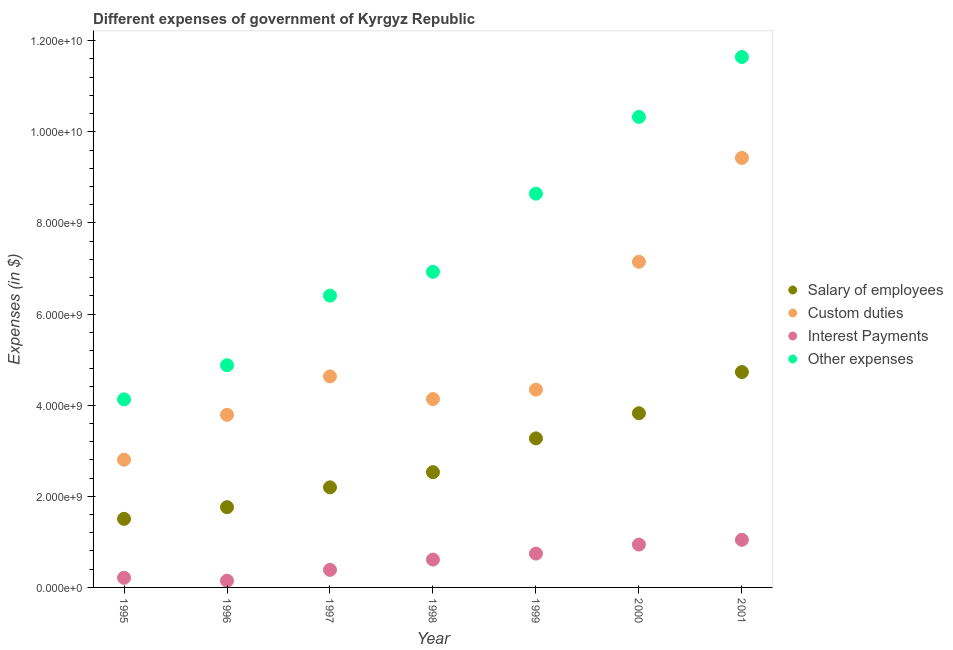Is the number of dotlines equal to the number of legend labels?
Your response must be concise. Yes. What is the amount spent on custom duties in 1999?
Give a very brief answer. 4.34e+09. Across all years, what is the maximum amount spent on salary of employees?
Your answer should be very brief. 4.73e+09. Across all years, what is the minimum amount spent on salary of employees?
Ensure brevity in your answer.  1.51e+09. In which year was the amount spent on custom duties maximum?
Keep it short and to the point. 2001. In which year was the amount spent on custom duties minimum?
Make the answer very short. 1995. What is the total amount spent on salary of employees in the graph?
Offer a very short reply. 1.98e+1. What is the difference between the amount spent on interest payments in 1995 and that in 1997?
Offer a very short reply. -1.74e+08. What is the difference between the amount spent on salary of employees in 1998 and the amount spent on other expenses in 1996?
Ensure brevity in your answer.  -2.35e+09. What is the average amount spent on salary of employees per year?
Ensure brevity in your answer.  2.83e+09. In the year 1995, what is the difference between the amount spent on custom duties and amount spent on other expenses?
Make the answer very short. -1.32e+09. In how many years, is the amount spent on salary of employees greater than 4800000000 $?
Provide a short and direct response. 0. What is the ratio of the amount spent on custom duties in 1996 to that in 1997?
Offer a very short reply. 0.82. Is the amount spent on salary of employees in 2000 less than that in 2001?
Your answer should be compact. Yes. Is the difference between the amount spent on custom duties in 1995 and 1997 greater than the difference between the amount spent on interest payments in 1995 and 1997?
Make the answer very short. No. What is the difference between the highest and the second highest amount spent on other expenses?
Your answer should be very brief. 1.32e+09. What is the difference between the highest and the lowest amount spent on other expenses?
Ensure brevity in your answer.  7.52e+09. In how many years, is the amount spent on other expenses greater than the average amount spent on other expenses taken over all years?
Keep it short and to the point. 3. Is it the case that in every year, the sum of the amount spent on other expenses and amount spent on custom duties is greater than the sum of amount spent on salary of employees and amount spent on interest payments?
Make the answer very short. Yes. Is it the case that in every year, the sum of the amount spent on salary of employees and amount spent on custom duties is greater than the amount spent on interest payments?
Provide a succinct answer. Yes. Does the amount spent on other expenses monotonically increase over the years?
Provide a succinct answer. Yes. Is the amount spent on other expenses strictly greater than the amount spent on salary of employees over the years?
Give a very brief answer. Yes. How many dotlines are there?
Provide a short and direct response. 4. What is the difference between two consecutive major ticks on the Y-axis?
Make the answer very short. 2.00e+09. Are the values on the major ticks of Y-axis written in scientific E-notation?
Your answer should be very brief. Yes. Does the graph contain any zero values?
Make the answer very short. No. Does the graph contain grids?
Keep it short and to the point. No. How many legend labels are there?
Your answer should be very brief. 4. What is the title of the graph?
Your answer should be compact. Different expenses of government of Kyrgyz Republic. Does "Revenue mobilization" appear as one of the legend labels in the graph?
Ensure brevity in your answer.  No. What is the label or title of the X-axis?
Make the answer very short. Year. What is the label or title of the Y-axis?
Ensure brevity in your answer.  Expenses (in $). What is the Expenses (in $) in Salary of employees in 1995?
Your response must be concise. 1.51e+09. What is the Expenses (in $) of Custom duties in 1995?
Make the answer very short. 2.80e+09. What is the Expenses (in $) of Interest Payments in 1995?
Give a very brief answer. 2.12e+08. What is the Expenses (in $) in Other expenses in 1995?
Give a very brief answer. 4.13e+09. What is the Expenses (in $) of Salary of employees in 1996?
Keep it short and to the point. 1.76e+09. What is the Expenses (in $) in Custom duties in 1996?
Your answer should be compact. 3.79e+09. What is the Expenses (in $) in Interest Payments in 1996?
Your answer should be very brief. 1.48e+08. What is the Expenses (in $) in Other expenses in 1996?
Give a very brief answer. 4.88e+09. What is the Expenses (in $) of Salary of employees in 1997?
Your answer should be compact. 2.20e+09. What is the Expenses (in $) in Custom duties in 1997?
Keep it short and to the point. 4.63e+09. What is the Expenses (in $) of Interest Payments in 1997?
Offer a terse response. 3.85e+08. What is the Expenses (in $) in Other expenses in 1997?
Offer a very short reply. 6.41e+09. What is the Expenses (in $) in Salary of employees in 1998?
Your answer should be compact. 2.53e+09. What is the Expenses (in $) of Custom duties in 1998?
Make the answer very short. 4.14e+09. What is the Expenses (in $) in Interest Payments in 1998?
Your response must be concise. 6.11e+08. What is the Expenses (in $) of Other expenses in 1998?
Give a very brief answer. 6.93e+09. What is the Expenses (in $) of Salary of employees in 1999?
Your answer should be compact. 3.27e+09. What is the Expenses (in $) in Custom duties in 1999?
Give a very brief answer. 4.34e+09. What is the Expenses (in $) of Interest Payments in 1999?
Offer a very short reply. 7.43e+08. What is the Expenses (in $) of Other expenses in 1999?
Your answer should be compact. 8.64e+09. What is the Expenses (in $) of Salary of employees in 2000?
Give a very brief answer. 3.82e+09. What is the Expenses (in $) of Custom duties in 2000?
Provide a short and direct response. 7.15e+09. What is the Expenses (in $) of Interest Payments in 2000?
Make the answer very short. 9.41e+08. What is the Expenses (in $) of Other expenses in 2000?
Your answer should be compact. 1.03e+1. What is the Expenses (in $) in Salary of employees in 2001?
Provide a short and direct response. 4.73e+09. What is the Expenses (in $) of Custom duties in 2001?
Make the answer very short. 9.43e+09. What is the Expenses (in $) of Interest Payments in 2001?
Ensure brevity in your answer.  1.05e+09. What is the Expenses (in $) in Other expenses in 2001?
Offer a terse response. 1.16e+1. Across all years, what is the maximum Expenses (in $) of Salary of employees?
Your answer should be compact. 4.73e+09. Across all years, what is the maximum Expenses (in $) in Custom duties?
Make the answer very short. 9.43e+09. Across all years, what is the maximum Expenses (in $) of Interest Payments?
Provide a succinct answer. 1.05e+09. Across all years, what is the maximum Expenses (in $) of Other expenses?
Provide a succinct answer. 1.16e+1. Across all years, what is the minimum Expenses (in $) of Salary of employees?
Provide a succinct answer. 1.51e+09. Across all years, what is the minimum Expenses (in $) in Custom duties?
Offer a terse response. 2.80e+09. Across all years, what is the minimum Expenses (in $) of Interest Payments?
Provide a short and direct response. 1.48e+08. Across all years, what is the minimum Expenses (in $) of Other expenses?
Keep it short and to the point. 4.13e+09. What is the total Expenses (in $) in Salary of employees in the graph?
Provide a short and direct response. 1.98e+1. What is the total Expenses (in $) in Custom duties in the graph?
Ensure brevity in your answer.  3.63e+1. What is the total Expenses (in $) of Interest Payments in the graph?
Ensure brevity in your answer.  4.09e+09. What is the total Expenses (in $) in Other expenses in the graph?
Keep it short and to the point. 5.30e+1. What is the difference between the Expenses (in $) of Salary of employees in 1995 and that in 1996?
Your answer should be compact. -2.56e+08. What is the difference between the Expenses (in $) of Custom duties in 1995 and that in 1996?
Make the answer very short. -9.86e+08. What is the difference between the Expenses (in $) of Interest Payments in 1995 and that in 1996?
Your answer should be compact. 6.33e+07. What is the difference between the Expenses (in $) in Other expenses in 1995 and that in 1996?
Your answer should be very brief. -7.50e+08. What is the difference between the Expenses (in $) of Salary of employees in 1995 and that in 1997?
Offer a very short reply. -6.91e+08. What is the difference between the Expenses (in $) of Custom duties in 1995 and that in 1997?
Ensure brevity in your answer.  -1.83e+09. What is the difference between the Expenses (in $) in Interest Payments in 1995 and that in 1997?
Your answer should be very brief. -1.74e+08. What is the difference between the Expenses (in $) of Other expenses in 1995 and that in 1997?
Your response must be concise. -2.28e+09. What is the difference between the Expenses (in $) of Salary of employees in 1995 and that in 1998?
Offer a terse response. -1.02e+09. What is the difference between the Expenses (in $) of Custom duties in 1995 and that in 1998?
Make the answer very short. -1.33e+09. What is the difference between the Expenses (in $) of Interest Payments in 1995 and that in 1998?
Your response must be concise. -4.00e+08. What is the difference between the Expenses (in $) in Other expenses in 1995 and that in 1998?
Your answer should be compact. -2.80e+09. What is the difference between the Expenses (in $) of Salary of employees in 1995 and that in 1999?
Make the answer very short. -1.77e+09. What is the difference between the Expenses (in $) of Custom duties in 1995 and that in 1999?
Your answer should be very brief. -1.54e+09. What is the difference between the Expenses (in $) in Interest Payments in 1995 and that in 1999?
Give a very brief answer. -5.31e+08. What is the difference between the Expenses (in $) of Other expenses in 1995 and that in 1999?
Offer a terse response. -4.52e+09. What is the difference between the Expenses (in $) of Salary of employees in 1995 and that in 2000?
Provide a short and direct response. -2.32e+09. What is the difference between the Expenses (in $) in Custom duties in 1995 and that in 2000?
Give a very brief answer. -4.35e+09. What is the difference between the Expenses (in $) in Interest Payments in 1995 and that in 2000?
Offer a terse response. -7.29e+08. What is the difference between the Expenses (in $) of Other expenses in 1995 and that in 2000?
Your answer should be compact. -6.20e+09. What is the difference between the Expenses (in $) in Salary of employees in 1995 and that in 2001?
Your answer should be compact. -3.22e+09. What is the difference between the Expenses (in $) in Custom duties in 1995 and that in 2001?
Your response must be concise. -6.63e+09. What is the difference between the Expenses (in $) of Interest Payments in 1995 and that in 2001?
Your answer should be compact. -8.34e+08. What is the difference between the Expenses (in $) of Other expenses in 1995 and that in 2001?
Provide a succinct answer. -7.52e+09. What is the difference between the Expenses (in $) in Salary of employees in 1996 and that in 1997?
Provide a succinct answer. -4.35e+08. What is the difference between the Expenses (in $) of Custom duties in 1996 and that in 1997?
Your response must be concise. -8.42e+08. What is the difference between the Expenses (in $) in Interest Payments in 1996 and that in 1997?
Offer a terse response. -2.37e+08. What is the difference between the Expenses (in $) in Other expenses in 1996 and that in 1997?
Make the answer very short. -1.53e+09. What is the difference between the Expenses (in $) in Salary of employees in 1996 and that in 1998?
Make the answer very short. -7.68e+08. What is the difference between the Expenses (in $) of Custom duties in 1996 and that in 1998?
Make the answer very short. -3.46e+08. What is the difference between the Expenses (in $) in Interest Payments in 1996 and that in 1998?
Your answer should be compact. -4.63e+08. What is the difference between the Expenses (in $) of Other expenses in 1996 and that in 1998?
Keep it short and to the point. -2.05e+09. What is the difference between the Expenses (in $) in Salary of employees in 1996 and that in 1999?
Offer a terse response. -1.51e+09. What is the difference between the Expenses (in $) in Custom duties in 1996 and that in 1999?
Offer a very short reply. -5.52e+08. What is the difference between the Expenses (in $) of Interest Payments in 1996 and that in 1999?
Provide a short and direct response. -5.95e+08. What is the difference between the Expenses (in $) of Other expenses in 1996 and that in 1999?
Offer a very short reply. -3.77e+09. What is the difference between the Expenses (in $) in Salary of employees in 1996 and that in 2000?
Your answer should be very brief. -2.06e+09. What is the difference between the Expenses (in $) in Custom duties in 1996 and that in 2000?
Provide a succinct answer. -3.36e+09. What is the difference between the Expenses (in $) in Interest Payments in 1996 and that in 2000?
Your answer should be very brief. -7.92e+08. What is the difference between the Expenses (in $) of Other expenses in 1996 and that in 2000?
Provide a succinct answer. -5.45e+09. What is the difference between the Expenses (in $) in Salary of employees in 1996 and that in 2001?
Offer a very short reply. -2.97e+09. What is the difference between the Expenses (in $) of Custom duties in 1996 and that in 2001?
Make the answer very short. -5.64e+09. What is the difference between the Expenses (in $) of Interest Payments in 1996 and that in 2001?
Ensure brevity in your answer.  -8.97e+08. What is the difference between the Expenses (in $) of Other expenses in 1996 and that in 2001?
Ensure brevity in your answer.  -6.77e+09. What is the difference between the Expenses (in $) of Salary of employees in 1997 and that in 1998?
Offer a very short reply. -3.33e+08. What is the difference between the Expenses (in $) of Custom duties in 1997 and that in 1998?
Make the answer very short. 4.96e+08. What is the difference between the Expenses (in $) in Interest Payments in 1997 and that in 1998?
Ensure brevity in your answer.  -2.26e+08. What is the difference between the Expenses (in $) of Other expenses in 1997 and that in 1998?
Ensure brevity in your answer.  -5.22e+08. What is the difference between the Expenses (in $) of Salary of employees in 1997 and that in 1999?
Offer a very short reply. -1.08e+09. What is the difference between the Expenses (in $) in Custom duties in 1997 and that in 1999?
Your response must be concise. 2.90e+08. What is the difference between the Expenses (in $) of Interest Payments in 1997 and that in 1999?
Your answer should be very brief. -3.58e+08. What is the difference between the Expenses (in $) of Other expenses in 1997 and that in 1999?
Offer a very short reply. -2.24e+09. What is the difference between the Expenses (in $) in Salary of employees in 1997 and that in 2000?
Provide a succinct answer. -1.63e+09. What is the difference between the Expenses (in $) of Custom duties in 1997 and that in 2000?
Keep it short and to the point. -2.52e+09. What is the difference between the Expenses (in $) of Interest Payments in 1997 and that in 2000?
Your response must be concise. -5.55e+08. What is the difference between the Expenses (in $) in Other expenses in 1997 and that in 2000?
Offer a very short reply. -3.92e+09. What is the difference between the Expenses (in $) in Salary of employees in 1997 and that in 2001?
Your response must be concise. -2.53e+09. What is the difference between the Expenses (in $) of Custom duties in 1997 and that in 2001?
Ensure brevity in your answer.  -4.80e+09. What is the difference between the Expenses (in $) in Interest Payments in 1997 and that in 2001?
Provide a short and direct response. -6.60e+08. What is the difference between the Expenses (in $) of Other expenses in 1997 and that in 2001?
Your answer should be very brief. -5.24e+09. What is the difference between the Expenses (in $) in Salary of employees in 1998 and that in 1999?
Your answer should be very brief. -7.42e+08. What is the difference between the Expenses (in $) of Custom duties in 1998 and that in 1999?
Your answer should be compact. -2.06e+08. What is the difference between the Expenses (in $) of Interest Payments in 1998 and that in 1999?
Provide a short and direct response. -1.32e+08. What is the difference between the Expenses (in $) in Other expenses in 1998 and that in 1999?
Give a very brief answer. -1.72e+09. What is the difference between the Expenses (in $) in Salary of employees in 1998 and that in 2000?
Provide a succinct answer. -1.29e+09. What is the difference between the Expenses (in $) in Custom duties in 1998 and that in 2000?
Offer a terse response. -3.01e+09. What is the difference between the Expenses (in $) in Interest Payments in 1998 and that in 2000?
Your answer should be very brief. -3.29e+08. What is the difference between the Expenses (in $) in Other expenses in 1998 and that in 2000?
Keep it short and to the point. -3.40e+09. What is the difference between the Expenses (in $) in Salary of employees in 1998 and that in 2001?
Keep it short and to the point. -2.20e+09. What is the difference between the Expenses (in $) of Custom duties in 1998 and that in 2001?
Your answer should be compact. -5.29e+09. What is the difference between the Expenses (in $) of Interest Payments in 1998 and that in 2001?
Offer a very short reply. -4.34e+08. What is the difference between the Expenses (in $) of Other expenses in 1998 and that in 2001?
Your response must be concise. -4.72e+09. What is the difference between the Expenses (in $) in Salary of employees in 1999 and that in 2000?
Your response must be concise. -5.52e+08. What is the difference between the Expenses (in $) in Custom duties in 1999 and that in 2000?
Ensure brevity in your answer.  -2.81e+09. What is the difference between the Expenses (in $) in Interest Payments in 1999 and that in 2000?
Your answer should be very brief. -1.98e+08. What is the difference between the Expenses (in $) in Other expenses in 1999 and that in 2000?
Offer a terse response. -1.68e+09. What is the difference between the Expenses (in $) in Salary of employees in 1999 and that in 2001?
Keep it short and to the point. -1.46e+09. What is the difference between the Expenses (in $) of Custom duties in 1999 and that in 2001?
Offer a very short reply. -5.09e+09. What is the difference between the Expenses (in $) in Interest Payments in 1999 and that in 2001?
Your answer should be compact. -3.02e+08. What is the difference between the Expenses (in $) of Other expenses in 1999 and that in 2001?
Offer a terse response. -3.00e+09. What is the difference between the Expenses (in $) of Salary of employees in 2000 and that in 2001?
Your answer should be very brief. -9.04e+08. What is the difference between the Expenses (in $) of Custom duties in 2000 and that in 2001?
Keep it short and to the point. -2.28e+09. What is the difference between the Expenses (in $) in Interest Payments in 2000 and that in 2001?
Your response must be concise. -1.05e+08. What is the difference between the Expenses (in $) in Other expenses in 2000 and that in 2001?
Give a very brief answer. -1.32e+09. What is the difference between the Expenses (in $) of Salary of employees in 1995 and the Expenses (in $) of Custom duties in 1996?
Keep it short and to the point. -2.28e+09. What is the difference between the Expenses (in $) in Salary of employees in 1995 and the Expenses (in $) in Interest Payments in 1996?
Your answer should be compact. 1.36e+09. What is the difference between the Expenses (in $) in Salary of employees in 1995 and the Expenses (in $) in Other expenses in 1996?
Keep it short and to the point. -3.37e+09. What is the difference between the Expenses (in $) of Custom duties in 1995 and the Expenses (in $) of Interest Payments in 1996?
Your answer should be compact. 2.65e+09. What is the difference between the Expenses (in $) of Custom duties in 1995 and the Expenses (in $) of Other expenses in 1996?
Your response must be concise. -2.07e+09. What is the difference between the Expenses (in $) in Interest Payments in 1995 and the Expenses (in $) in Other expenses in 1996?
Make the answer very short. -4.67e+09. What is the difference between the Expenses (in $) of Salary of employees in 1995 and the Expenses (in $) of Custom duties in 1997?
Your answer should be very brief. -3.13e+09. What is the difference between the Expenses (in $) of Salary of employees in 1995 and the Expenses (in $) of Interest Payments in 1997?
Make the answer very short. 1.12e+09. What is the difference between the Expenses (in $) of Salary of employees in 1995 and the Expenses (in $) of Other expenses in 1997?
Offer a very short reply. -4.90e+09. What is the difference between the Expenses (in $) of Custom duties in 1995 and the Expenses (in $) of Interest Payments in 1997?
Your answer should be very brief. 2.42e+09. What is the difference between the Expenses (in $) in Custom duties in 1995 and the Expenses (in $) in Other expenses in 1997?
Your answer should be compact. -3.60e+09. What is the difference between the Expenses (in $) in Interest Payments in 1995 and the Expenses (in $) in Other expenses in 1997?
Provide a short and direct response. -6.19e+09. What is the difference between the Expenses (in $) in Salary of employees in 1995 and the Expenses (in $) in Custom duties in 1998?
Your answer should be compact. -2.63e+09. What is the difference between the Expenses (in $) of Salary of employees in 1995 and the Expenses (in $) of Interest Payments in 1998?
Keep it short and to the point. 8.94e+08. What is the difference between the Expenses (in $) of Salary of employees in 1995 and the Expenses (in $) of Other expenses in 1998?
Keep it short and to the point. -5.42e+09. What is the difference between the Expenses (in $) in Custom duties in 1995 and the Expenses (in $) in Interest Payments in 1998?
Your answer should be very brief. 2.19e+09. What is the difference between the Expenses (in $) of Custom duties in 1995 and the Expenses (in $) of Other expenses in 1998?
Your answer should be compact. -4.12e+09. What is the difference between the Expenses (in $) of Interest Payments in 1995 and the Expenses (in $) of Other expenses in 1998?
Give a very brief answer. -6.72e+09. What is the difference between the Expenses (in $) in Salary of employees in 1995 and the Expenses (in $) in Custom duties in 1999?
Your answer should be compact. -2.84e+09. What is the difference between the Expenses (in $) in Salary of employees in 1995 and the Expenses (in $) in Interest Payments in 1999?
Ensure brevity in your answer.  7.62e+08. What is the difference between the Expenses (in $) of Salary of employees in 1995 and the Expenses (in $) of Other expenses in 1999?
Provide a succinct answer. -7.14e+09. What is the difference between the Expenses (in $) of Custom duties in 1995 and the Expenses (in $) of Interest Payments in 1999?
Offer a very short reply. 2.06e+09. What is the difference between the Expenses (in $) of Custom duties in 1995 and the Expenses (in $) of Other expenses in 1999?
Your answer should be very brief. -5.84e+09. What is the difference between the Expenses (in $) of Interest Payments in 1995 and the Expenses (in $) of Other expenses in 1999?
Your answer should be compact. -8.43e+09. What is the difference between the Expenses (in $) of Salary of employees in 1995 and the Expenses (in $) of Custom duties in 2000?
Provide a succinct answer. -5.64e+09. What is the difference between the Expenses (in $) in Salary of employees in 1995 and the Expenses (in $) in Interest Payments in 2000?
Your answer should be very brief. 5.65e+08. What is the difference between the Expenses (in $) in Salary of employees in 1995 and the Expenses (in $) in Other expenses in 2000?
Give a very brief answer. -8.82e+09. What is the difference between the Expenses (in $) in Custom duties in 1995 and the Expenses (in $) in Interest Payments in 2000?
Your answer should be very brief. 1.86e+09. What is the difference between the Expenses (in $) in Custom duties in 1995 and the Expenses (in $) in Other expenses in 2000?
Your response must be concise. -7.52e+09. What is the difference between the Expenses (in $) in Interest Payments in 1995 and the Expenses (in $) in Other expenses in 2000?
Give a very brief answer. -1.01e+1. What is the difference between the Expenses (in $) in Salary of employees in 1995 and the Expenses (in $) in Custom duties in 2001?
Your answer should be very brief. -7.92e+09. What is the difference between the Expenses (in $) of Salary of employees in 1995 and the Expenses (in $) of Interest Payments in 2001?
Give a very brief answer. 4.60e+08. What is the difference between the Expenses (in $) in Salary of employees in 1995 and the Expenses (in $) in Other expenses in 2001?
Make the answer very short. -1.01e+1. What is the difference between the Expenses (in $) in Custom duties in 1995 and the Expenses (in $) in Interest Payments in 2001?
Ensure brevity in your answer.  1.76e+09. What is the difference between the Expenses (in $) of Custom duties in 1995 and the Expenses (in $) of Other expenses in 2001?
Make the answer very short. -8.84e+09. What is the difference between the Expenses (in $) in Interest Payments in 1995 and the Expenses (in $) in Other expenses in 2001?
Offer a terse response. -1.14e+1. What is the difference between the Expenses (in $) in Salary of employees in 1996 and the Expenses (in $) in Custom duties in 1997?
Keep it short and to the point. -2.87e+09. What is the difference between the Expenses (in $) of Salary of employees in 1996 and the Expenses (in $) of Interest Payments in 1997?
Provide a short and direct response. 1.38e+09. What is the difference between the Expenses (in $) of Salary of employees in 1996 and the Expenses (in $) of Other expenses in 1997?
Make the answer very short. -4.64e+09. What is the difference between the Expenses (in $) of Custom duties in 1996 and the Expenses (in $) of Interest Payments in 1997?
Your response must be concise. 3.40e+09. What is the difference between the Expenses (in $) in Custom duties in 1996 and the Expenses (in $) in Other expenses in 1997?
Give a very brief answer. -2.62e+09. What is the difference between the Expenses (in $) of Interest Payments in 1996 and the Expenses (in $) of Other expenses in 1997?
Give a very brief answer. -6.26e+09. What is the difference between the Expenses (in $) of Salary of employees in 1996 and the Expenses (in $) of Custom duties in 1998?
Provide a short and direct response. -2.37e+09. What is the difference between the Expenses (in $) of Salary of employees in 1996 and the Expenses (in $) of Interest Payments in 1998?
Ensure brevity in your answer.  1.15e+09. What is the difference between the Expenses (in $) in Salary of employees in 1996 and the Expenses (in $) in Other expenses in 1998?
Ensure brevity in your answer.  -5.17e+09. What is the difference between the Expenses (in $) in Custom duties in 1996 and the Expenses (in $) in Interest Payments in 1998?
Ensure brevity in your answer.  3.18e+09. What is the difference between the Expenses (in $) in Custom duties in 1996 and the Expenses (in $) in Other expenses in 1998?
Keep it short and to the point. -3.14e+09. What is the difference between the Expenses (in $) of Interest Payments in 1996 and the Expenses (in $) of Other expenses in 1998?
Provide a succinct answer. -6.78e+09. What is the difference between the Expenses (in $) in Salary of employees in 1996 and the Expenses (in $) in Custom duties in 1999?
Your answer should be very brief. -2.58e+09. What is the difference between the Expenses (in $) in Salary of employees in 1996 and the Expenses (in $) in Interest Payments in 1999?
Keep it short and to the point. 1.02e+09. What is the difference between the Expenses (in $) of Salary of employees in 1996 and the Expenses (in $) of Other expenses in 1999?
Your answer should be compact. -6.88e+09. What is the difference between the Expenses (in $) of Custom duties in 1996 and the Expenses (in $) of Interest Payments in 1999?
Offer a terse response. 3.05e+09. What is the difference between the Expenses (in $) in Custom duties in 1996 and the Expenses (in $) in Other expenses in 1999?
Provide a short and direct response. -4.85e+09. What is the difference between the Expenses (in $) in Interest Payments in 1996 and the Expenses (in $) in Other expenses in 1999?
Provide a short and direct response. -8.50e+09. What is the difference between the Expenses (in $) of Salary of employees in 1996 and the Expenses (in $) of Custom duties in 2000?
Your answer should be compact. -5.39e+09. What is the difference between the Expenses (in $) in Salary of employees in 1996 and the Expenses (in $) in Interest Payments in 2000?
Provide a short and direct response. 8.21e+08. What is the difference between the Expenses (in $) of Salary of employees in 1996 and the Expenses (in $) of Other expenses in 2000?
Keep it short and to the point. -8.57e+09. What is the difference between the Expenses (in $) of Custom duties in 1996 and the Expenses (in $) of Interest Payments in 2000?
Provide a succinct answer. 2.85e+09. What is the difference between the Expenses (in $) of Custom duties in 1996 and the Expenses (in $) of Other expenses in 2000?
Provide a succinct answer. -6.54e+09. What is the difference between the Expenses (in $) of Interest Payments in 1996 and the Expenses (in $) of Other expenses in 2000?
Offer a terse response. -1.02e+1. What is the difference between the Expenses (in $) in Salary of employees in 1996 and the Expenses (in $) in Custom duties in 2001?
Provide a short and direct response. -7.67e+09. What is the difference between the Expenses (in $) of Salary of employees in 1996 and the Expenses (in $) of Interest Payments in 2001?
Offer a terse response. 7.16e+08. What is the difference between the Expenses (in $) in Salary of employees in 1996 and the Expenses (in $) in Other expenses in 2001?
Provide a short and direct response. -9.88e+09. What is the difference between the Expenses (in $) in Custom duties in 1996 and the Expenses (in $) in Interest Payments in 2001?
Provide a short and direct response. 2.74e+09. What is the difference between the Expenses (in $) in Custom duties in 1996 and the Expenses (in $) in Other expenses in 2001?
Your response must be concise. -7.85e+09. What is the difference between the Expenses (in $) in Interest Payments in 1996 and the Expenses (in $) in Other expenses in 2001?
Your answer should be very brief. -1.15e+1. What is the difference between the Expenses (in $) in Salary of employees in 1997 and the Expenses (in $) in Custom duties in 1998?
Keep it short and to the point. -1.94e+09. What is the difference between the Expenses (in $) in Salary of employees in 1997 and the Expenses (in $) in Interest Payments in 1998?
Your answer should be very brief. 1.59e+09. What is the difference between the Expenses (in $) of Salary of employees in 1997 and the Expenses (in $) of Other expenses in 1998?
Make the answer very short. -4.73e+09. What is the difference between the Expenses (in $) of Custom duties in 1997 and the Expenses (in $) of Interest Payments in 1998?
Your answer should be compact. 4.02e+09. What is the difference between the Expenses (in $) of Custom duties in 1997 and the Expenses (in $) of Other expenses in 1998?
Your response must be concise. -2.30e+09. What is the difference between the Expenses (in $) in Interest Payments in 1997 and the Expenses (in $) in Other expenses in 1998?
Make the answer very short. -6.54e+09. What is the difference between the Expenses (in $) in Salary of employees in 1997 and the Expenses (in $) in Custom duties in 1999?
Make the answer very short. -2.15e+09. What is the difference between the Expenses (in $) in Salary of employees in 1997 and the Expenses (in $) in Interest Payments in 1999?
Your answer should be very brief. 1.45e+09. What is the difference between the Expenses (in $) of Salary of employees in 1997 and the Expenses (in $) of Other expenses in 1999?
Keep it short and to the point. -6.45e+09. What is the difference between the Expenses (in $) of Custom duties in 1997 and the Expenses (in $) of Interest Payments in 1999?
Keep it short and to the point. 3.89e+09. What is the difference between the Expenses (in $) in Custom duties in 1997 and the Expenses (in $) in Other expenses in 1999?
Offer a terse response. -4.01e+09. What is the difference between the Expenses (in $) of Interest Payments in 1997 and the Expenses (in $) of Other expenses in 1999?
Offer a very short reply. -8.26e+09. What is the difference between the Expenses (in $) of Salary of employees in 1997 and the Expenses (in $) of Custom duties in 2000?
Your answer should be compact. -4.95e+09. What is the difference between the Expenses (in $) in Salary of employees in 1997 and the Expenses (in $) in Interest Payments in 2000?
Provide a short and direct response. 1.26e+09. What is the difference between the Expenses (in $) in Salary of employees in 1997 and the Expenses (in $) in Other expenses in 2000?
Ensure brevity in your answer.  -8.13e+09. What is the difference between the Expenses (in $) of Custom duties in 1997 and the Expenses (in $) of Interest Payments in 2000?
Give a very brief answer. 3.69e+09. What is the difference between the Expenses (in $) in Custom duties in 1997 and the Expenses (in $) in Other expenses in 2000?
Provide a short and direct response. -5.70e+09. What is the difference between the Expenses (in $) in Interest Payments in 1997 and the Expenses (in $) in Other expenses in 2000?
Your answer should be very brief. -9.94e+09. What is the difference between the Expenses (in $) in Salary of employees in 1997 and the Expenses (in $) in Custom duties in 2001?
Your response must be concise. -7.23e+09. What is the difference between the Expenses (in $) of Salary of employees in 1997 and the Expenses (in $) of Interest Payments in 2001?
Make the answer very short. 1.15e+09. What is the difference between the Expenses (in $) of Salary of employees in 1997 and the Expenses (in $) of Other expenses in 2001?
Give a very brief answer. -9.45e+09. What is the difference between the Expenses (in $) of Custom duties in 1997 and the Expenses (in $) of Interest Payments in 2001?
Your answer should be compact. 3.59e+09. What is the difference between the Expenses (in $) in Custom duties in 1997 and the Expenses (in $) in Other expenses in 2001?
Your response must be concise. -7.01e+09. What is the difference between the Expenses (in $) of Interest Payments in 1997 and the Expenses (in $) of Other expenses in 2001?
Ensure brevity in your answer.  -1.13e+1. What is the difference between the Expenses (in $) of Salary of employees in 1998 and the Expenses (in $) of Custom duties in 1999?
Give a very brief answer. -1.81e+09. What is the difference between the Expenses (in $) in Salary of employees in 1998 and the Expenses (in $) in Interest Payments in 1999?
Make the answer very short. 1.79e+09. What is the difference between the Expenses (in $) in Salary of employees in 1998 and the Expenses (in $) in Other expenses in 1999?
Provide a short and direct response. -6.11e+09. What is the difference between the Expenses (in $) in Custom duties in 1998 and the Expenses (in $) in Interest Payments in 1999?
Provide a succinct answer. 3.39e+09. What is the difference between the Expenses (in $) of Custom duties in 1998 and the Expenses (in $) of Other expenses in 1999?
Make the answer very short. -4.51e+09. What is the difference between the Expenses (in $) in Interest Payments in 1998 and the Expenses (in $) in Other expenses in 1999?
Offer a terse response. -8.03e+09. What is the difference between the Expenses (in $) in Salary of employees in 1998 and the Expenses (in $) in Custom duties in 2000?
Give a very brief answer. -4.62e+09. What is the difference between the Expenses (in $) of Salary of employees in 1998 and the Expenses (in $) of Interest Payments in 2000?
Your answer should be very brief. 1.59e+09. What is the difference between the Expenses (in $) of Salary of employees in 1998 and the Expenses (in $) of Other expenses in 2000?
Provide a short and direct response. -7.80e+09. What is the difference between the Expenses (in $) of Custom duties in 1998 and the Expenses (in $) of Interest Payments in 2000?
Make the answer very short. 3.19e+09. What is the difference between the Expenses (in $) in Custom duties in 1998 and the Expenses (in $) in Other expenses in 2000?
Provide a succinct answer. -6.19e+09. What is the difference between the Expenses (in $) in Interest Payments in 1998 and the Expenses (in $) in Other expenses in 2000?
Your answer should be very brief. -9.72e+09. What is the difference between the Expenses (in $) of Salary of employees in 1998 and the Expenses (in $) of Custom duties in 2001?
Offer a terse response. -6.90e+09. What is the difference between the Expenses (in $) in Salary of employees in 1998 and the Expenses (in $) in Interest Payments in 2001?
Your response must be concise. 1.48e+09. What is the difference between the Expenses (in $) of Salary of employees in 1998 and the Expenses (in $) of Other expenses in 2001?
Keep it short and to the point. -9.11e+09. What is the difference between the Expenses (in $) in Custom duties in 1998 and the Expenses (in $) in Interest Payments in 2001?
Your response must be concise. 3.09e+09. What is the difference between the Expenses (in $) of Custom duties in 1998 and the Expenses (in $) of Other expenses in 2001?
Your answer should be compact. -7.51e+09. What is the difference between the Expenses (in $) of Interest Payments in 1998 and the Expenses (in $) of Other expenses in 2001?
Offer a terse response. -1.10e+1. What is the difference between the Expenses (in $) of Salary of employees in 1999 and the Expenses (in $) of Custom duties in 2000?
Provide a short and direct response. -3.88e+09. What is the difference between the Expenses (in $) of Salary of employees in 1999 and the Expenses (in $) of Interest Payments in 2000?
Your answer should be compact. 2.33e+09. What is the difference between the Expenses (in $) in Salary of employees in 1999 and the Expenses (in $) in Other expenses in 2000?
Provide a succinct answer. -7.06e+09. What is the difference between the Expenses (in $) of Custom duties in 1999 and the Expenses (in $) of Interest Payments in 2000?
Make the answer very short. 3.40e+09. What is the difference between the Expenses (in $) of Custom duties in 1999 and the Expenses (in $) of Other expenses in 2000?
Offer a terse response. -5.99e+09. What is the difference between the Expenses (in $) of Interest Payments in 1999 and the Expenses (in $) of Other expenses in 2000?
Your response must be concise. -9.59e+09. What is the difference between the Expenses (in $) of Salary of employees in 1999 and the Expenses (in $) of Custom duties in 2001?
Offer a very short reply. -6.16e+09. What is the difference between the Expenses (in $) of Salary of employees in 1999 and the Expenses (in $) of Interest Payments in 2001?
Your answer should be very brief. 2.23e+09. What is the difference between the Expenses (in $) of Salary of employees in 1999 and the Expenses (in $) of Other expenses in 2001?
Your answer should be very brief. -8.37e+09. What is the difference between the Expenses (in $) in Custom duties in 1999 and the Expenses (in $) in Interest Payments in 2001?
Ensure brevity in your answer.  3.30e+09. What is the difference between the Expenses (in $) in Custom duties in 1999 and the Expenses (in $) in Other expenses in 2001?
Give a very brief answer. -7.30e+09. What is the difference between the Expenses (in $) of Interest Payments in 1999 and the Expenses (in $) of Other expenses in 2001?
Offer a very short reply. -1.09e+1. What is the difference between the Expenses (in $) of Salary of employees in 2000 and the Expenses (in $) of Custom duties in 2001?
Make the answer very short. -5.61e+09. What is the difference between the Expenses (in $) of Salary of employees in 2000 and the Expenses (in $) of Interest Payments in 2001?
Provide a short and direct response. 2.78e+09. What is the difference between the Expenses (in $) of Salary of employees in 2000 and the Expenses (in $) of Other expenses in 2001?
Provide a short and direct response. -7.82e+09. What is the difference between the Expenses (in $) of Custom duties in 2000 and the Expenses (in $) of Interest Payments in 2001?
Provide a succinct answer. 6.10e+09. What is the difference between the Expenses (in $) of Custom duties in 2000 and the Expenses (in $) of Other expenses in 2001?
Provide a succinct answer. -4.49e+09. What is the difference between the Expenses (in $) in Interest Payments in 2000 and the Expenses (in $) in Other expenses in 2001?
Offer a very short reply. -1.07e+1. What is the average Expenses (in $) in Salary of employees per year?
Your response must be concise. 2.83e+09. What is the average Expenses (in $) in Custom duties per year?
Provide a succinct answer. 5.18e+09. What is the average Expenses (in $) in Interest Payments per year?
Ensure brevity in your answer.  5.84e+08. What is the average Expenses (in $) of Other expenses per year?
Your response must be concise. 7.57e+09. In the year 1995, what is the difference between the Expenses (in $) in Salary of employees and Expenses (in $) in Custom duties?
Your answer should be very brief. -1.30e+09. In the year 1995, what is the difference between the Expenses (in $) of Salary of employees and Expenses (in $) of Interest Payments?
Ensure brevity in your answer.  1.29e+09. In the year 1995, what is the difference between the Expenses (in $) in Salary of employees and Expenses (in $) in Other expenses?
Offer a terse response. -2.62e+09. In the year 1995, what is the difference between the Expenses (in $) of Custom duties and Expenses (in $) of Interest Payments?
Provide a succinct answer. 2.59e+09. In the year 1995, what is the difference between the Expenses (in $) in Custom duties and Expenses (in $) in Other expenses?
Offer a very short reply. -1.32e+09. In the year 1995, what is the difference between the Expenses (in $) of Interest Payments and Expenses (in $) of Other expenses?
Offer a very short reply. -3.92e+09. In the year 1996, what is the difference between the Expenses (in $) in Salary of employees and Expenses (in $) in Custom duties?
Offer a terse response. -2.03e+09. In the year 1996, what is the difference between the Expenses (in $) in Salary of employees and Expenses (in $) in Interest Payments?
Your answer should be compact. 1.61e+09. In the year 1996, what is the difference between the Expenses (in $) in Salary of employees and Expenses (in $) in Other expenses?
Make the answer very short. -3.12e+09. In the year 1996, what is the difference between the Expenses (in $) of Custom duties and Expenses (in $) of Interest Payments?
Offer a terse response. 3.64e+09. In the year 1996, what is the difference between the Expenses (in $) in Custom duties and Expenses (in $) in Other expenses?
Offer a very short reply. -1.09e+09. In the year 1996, what is the difference between the Expenses (in $) in Interest Payments and Expenses (in $) in Other expenses?
Keep it short and to the point. -4.73e+09. In the year 1997, what is the difference between the Expenses (in $) of Salary of employees and Expenses (in $) of Custom duties?
Provide a short and direct response. -2.44e+09. In the year 1997, what is the difference between the Expenses (in $) in Salary of employees and Expenses (in $) in Interest Payments?
Your answer should be compact. 1.81e+09. In the year 1997, what is the difference between the Expenses (in $) in Salary of employees and Expenses (in $) in Other expenses?
Your answer should be very brief. -4.21e+09. In the year 1997, what is the difference between the Expenses (in $) of Custom duties and Expenses (in $) of Interest Payments?
Provide a short and direct response. 4.25e+09. In the year 1997, what is the difference between the Expenses (in $) in Custom duties and Expenses (in $) in Other expenses?
Keep it short and to the point. -1.77e+09. In the year 1997, what is the difference between the Expenses (in $) in Interest Payments and Expenses (in $) in Other expenses?
Your response must be concise. -6.02e+09. In the year 1998, what is the difference between the Expenses (in $) of Salary of employees and Expenses (in $) of Custom duties?
Give a very brief answer. -1.61e+09. In the year 1998, what is the difference between the Expenses (in $) in Salary of employees and Expenses (in $) in Interest Payments?
Provide a succinct answer. 1.92e+09. In the year 1998, what is the difference between the Expenses (in $) of Salary of employees and Expenses (in $) of Other expenses?
Your answer should be compact. -4.40e+09. In the year 1998, what is the difference between the Expenses (in $) of Custom duties and Expenses (in $) of Interest Payments?
Your answer should be compact. 3.52e+09. In the year 1998, what is the difference between the Expenses (in $) of Custom duties and Expenses (in $) of Other expenses?
Make the answer very short. -2.79e+09. In the year 1998, what is the difference between the Expenses (in $) in Interest Payments and Expenses (in $) in Other expenses?
Ensure brevity in your answer.  -6.32e+09. In the year 1999, what is the difference between the Expenses (in $) in Salary of employees and Expenses (in $) in Custom duties?
Your response must be concise. -1.07e+09. In the year 1999, what is the difference between the Expenses (in $) in Salary of employees and Expenses (in $) in Interest Payments?
Offer a very short reply. 2.53e+09. In the year 1999, what is the difference between the Expenses (in $) of Salary of employees and Expenses (in $) of Other expenses?
Your answer should be very brief. -5.37e+09. In the year 1999, what is the difference between the Expenses (in $) of Custom duties and Expenses (in $) of Interest Payments?
Offer a very short reply. 3.60e+09. In the year 1999, what is the difference between the Expenses (in $) of Custom duties and Expenses (in $) of Other expenses?
Keep it short and to the point. -4.30e+09. In the year 1999, what is the difference between the Expenses (in $) of Interest Payments and Expenses (in $) of Other expenses?
Ensure brevity in your answer.  -7.90e+09. In the year 2000, what is the difference between the Expenses (in $) in Salary of employees and Expenses (in $) in Custom duties?
Provide a short and direct response. -3.33e+09. In the year 2000, what is the difference between the Expenses (in $) of Salary of employees and Expenses (in $) of Interest Payments?
Provide a short and direct response. 2.88e+09. In the year 2000, what is the difference between the Expenses (in $) of Salary of employees and Expenses (in $) of Other expenses?
Give a very brief answer. -6.50e+09. In the year 2000, what is the difference between the Expenses (in $) of Custom duties and Expenses (in $) of Interest Payments?
Your response must be concise. 6.21e+09. In the year 2000, what is the difference between the Expenses (in $) of Custom duties and Expenses (in $) of Other expenses?
Give a very brief answer. -3.18e+09. In the year 2000, what is the difference between the Expenses (in $) of Interest Payments and Expenses (in $) of Other expenses?
Your answer should be compact. -9.39e+09. In the year 2001, what is the difference between the Expenses (in $) in Salary of employees and Expenses (in $) in Custom duties?
Your response must be concise. -4.70e+09. In the year 2001, what is the difference between the Expenses (in $) in Salary of employees and Expenses (in $) in Interest Payments?
Make the answer very short. 3.68e+09. In the year 2001, what is the difference between the Expenses (in $) in Salary of employees and Expenses (in $) in Other expenses?
Your response must be concise. -6.92e+09. In the year 2001, what is the difference between the Expenses (in $) in Custom duties and Expenses (in $) in Interest Payments?
Give a very brief answer. 8.38e+09. In the year 2001, what is the difference between the Expenses (in $) of Custom duties and Expenses (in $) of Other expenses?
Provide a short and direct response. -2.21e+09. In the year 2001, what is the difference between the Expenses (in $) in Interest Payments and Expenses (in $) in Other expenses?
Make the answer very short. -1.06e+1. What is the ratio of the Expenses (in $) in Salary of employees in 1995 to that in 1996?
Your response must be concise. 0.85. What is the ratio of the Expenses (in $) of Custom duties in 1995 to that in 1996?
Provide a short and direct response. 0.74. What is the ratio of the Expenses (in $) in Interest Payments in 1995 to that in 1996?
Offer a very short reply. 1.43. What is the ratio of the Expenses (in $) in Other expenses in 1995 to that in 1996?
Offer a terse response. 0.85. What is the ratio of the Expenses (in $) of Salary of employees in 1995 to that in 1997?
Give a very brief answer. 0.69. What is the ratio of the Expenses (in $) of Custom duties in 1995 to that in 1997?
Offer a very short reply. 0.61. What is the ratio of the Expenses (in $) in Interest Payments in 1995 to that in 1997?
Provide a succinct answer. 0.55. What is the ratio of the Expenses (in $) in Other expenses in 1995 to that in 1997?
Your response must be concise. 0.64. What is the ratio of the Expenses (in $) of Salary of employees in 1995 to that in 1998?
Your response must be concise. 0.59. What is the ratio of the Expenses (in $) of Custom duties in 1995 to that in 1998?
Provide a succinct answer. 0.68. What is the ratio of the Expenses (in $) of Interest Payments in 1995 to that in 1998?
Give a very brief answer. 0.35. What is the ratio of the Expenses (in $) of Other expenses in 1995 to that in 1998?
Keep it short and to the point. 0.6. What is the ratio of the Expenses (in $) of Salary of employees in 1995 to that in 1999?
Make the answer very short. 0.46. What is the ratio of the Expenses (in $) in Custom duties in 1995 to that in 1999?
Keep it short and to the point. 0.65. What is the ratio of the Expenses (in $) in Interest Payments in 1995 to that in 1999?
Your response must be concise. 0.28. What is the ratio of the Expenses (in $) in Other expenses in 1995 to that in 1999?
Keep it short and to the point. 0.48. What is the ratio of the Expenses (in $) in Salary of employees in 1995 to that in 2000?
Your answer should be compact. 0.39. What is the ratio of the Expenses (in $) in Custom duties in 1995 to that in 2000?
Provide a succinct answer. 0.39. What is the ratio of the Expenses (in $) in Interest Payments in 1995 to that in 2000?
Keep it short and to the point. 0.23. What is the ratio of the Expenses (in $) of Other expenses in 1995 to that in 2000?
Provide a short and direct response. 0.4. What is the ratio of the Expenses (in $) of Salary of employees in 1995 to that in 2001?
Give a very brief answer. 0.32. What is the ratio of the Expenses (in $) in Custom duties in 1995 to that in 2001?
Ensure brevity in your answer.  0.3. What is the ratio of the Expenses (in $) of Interest Payments in 1995 to that in 2001?
Offer a terse response. 0.2. What is the ratio of the Expenses (in $) of Other expenses in 1995 to that in 2001?
Your answer should be very brief. 0.35. What is the ratio of the Expenses (in $) in Salary of employees in 1996 to that in 1997?
Ensure brevity in your answer.  0.8. What is the ratio of the Expenses (in $) in Custom duties in 1996 to that in 1997?
Your answer should be compact. 0.82. What is the ratio of the Expenses (in $) of Interest Payments in 1996 to that in 1997?
Your answer should be very brief. 0.38. What is the ratio of the Expenses (in $) of Other expenses in 1996 to that in 1997?
Your response must be concise. 0.76. What is the ratio of the Expenses (in $) of Salary of employees in 1996 to that in 1998?
Make the answer very short. 0.7. What is the ratio of the Expenses (in $) in Custom duties in 1996 to that in 1998?
Ensure brevity in your answer.  0.92. What is the ratio of the Expenses (in $) in Interest Payments in 1996 to that in 1998?
Give a very brief answer. 0.24. What is the ratio of the Expenses (in $) of Other expenses in 1996 to that in 1998?
Your response must be concise. 0.7. What is the ratio of the Expenses (in $) in Salary of employees in 1996 to that in 1999?
Give a very brief answer. 0.54. What is the ratio of the Expenses (in $) in Custom duties in 1996 to that in 1999?
Provide a succinct answer. 0.87. What is the ratio of the Expenses (in $) of Interest Payments in 1996 to that in 1999?
Ensure brevity in your answer.  0.2. What is the ratio of the Expenses (in $) of Other expenses in 1996 to that in 1999?
Your response must be concise. 0.56. What is the ratio of the Expenses (in $) in Salary of employees in 1996 to that in 2000?
Offer a terse response. 0.46. What is the ratio of the Expenses (in $) in Custom duties in 1996 to that in 2000?
Provide a succinct answer. 0.53. What is the ratio of the Expenses (in $) in Interest Payments in 1996 to that in 2000?
Your answer should be compact. 0.16. What is the ratio of the Expenses (in $) in Other expenses in 1996 to that in 2000?
Make the answer very short. 0.47. What is the ratio of the Expenses (in $) of Salary of employees in 1996 to that in 2001?
Your answer should be very brief. 0.37. What is the ratio of the Expenses (in $) in Custom duties in 1996 to that in 2001?
Provide a succinct answer. 0.4. What is the ratio of the Expenses (in $) in Interest Payments in 1996 to that in 2001?
Your answer should be very brief. 0.14. What is the ratio of the Expenses (in $) in Other expenses in 1996 to that in 2001?
Offer a very short reply. 0.42. What is the ratio of the Expenses (in $) of Salary of employees in 1997 to that in 1998?
Your answer should be very brief. 0.87. What is the ratio of the Expenses (in $) in Custom duties in 1997 to that in 1998?
Provide a succinct answer. 1.12. What is the ratio of the Expenses (in $) of Interest Payments in 1997 to that in 1998?
Make the answer very short. 0.63. What is the ratio of the Expenses (in $) of Other expenses in 1997 to that in 1998?
Your response must be concise. 0.92. What is the ratio of the Expenses (in $) of Salary of employees in 1997 to that in 1999?
Offer a very short reply. 0.67. What is the ratio of the Expenses (in $) of Custom duties in 1997 to that in 1999?
Offer a very short reply. 1.07. What is the ratio of the Expenses (in $) of Interest Payments in 1997 to that in 1999?
Give a very brief answer. 0.52. What is the ratio of the Expenses (in $) of Other expenses in 1997 to that in 1999?
Give a very brief answer. 0.74. What is the ratio of the Expenses (in $) in Salary of employees in 1997 to that in 2000?
Make the answer very short. 0.57. What is the ratio of the Expenses (in $) in Custom duties in 1997 to that in 2000?
Ensure brevity in your answer.  0.65. What is the ratio of the Expenses (in $) of Interest Payments in 1997 to that in 2000?
Your answer should be very brief. 0.41. What is the ratio of the Expenses (in $) of Other expenses in 1997 to that in 2000?
Make the answer very short. 0.62. What is the ratio of the Expenses (in $) in Salary of employees in 1997 to that in 2001?
Make the answer very short. 0.46. What is the ratio of the Expenses (in $) in Custom duties in 1997 to that in 2001?
Offer a very short reply. 0.49. What is the ratio of the Expenses (in $) of Interest Payments in 1997 to that in 2001?
Your answer should be very brief. 0.37. What is the ratio of the Expenses (in $) of Other expenses in 1997 to that in 2001?
Provide a succinct answer. 0.55. What is the ratio of the Expenses (in $) of Salary of employees in 1998 to that in 1999?
Your answer should be very brief. 0.77. What is the ratio of the Expenses (in $) in Custom duties in 1998 to that in 1999?
Ensure brevity in your answer.  0.95. What is the ratio of the Expenses (in $) of Interest Payments in 1998 to that in 1999?
Offer a terse response. 0.82. What is the ratio of the Expenses (in $) in Other expenses in 1998 to that in 1999?
Provide a short and direct response. 0.8. What is the ratio of the Expenses (in $) of Salary of employees in 1998 to that in 2000?
Your answer should be compact. 0.66. What is the ratio of the Expenses (in $) in Custom duties in 1998 to that in 2000?
Ensure brevity in your answer.  0.58. What is the ratio of the Expenses (in $) of Interest Payments in 1998 to that in 2000?
Your response must be concise. 0.65. What is the ratio of the Expenses (in $) in Other expenses in 1998 to that in 2000?
Provide a succinct answer. 0.67. What is the ratio of the Expenses (in $) of Salary of employees in 1998 to that in 2001?
Your answer should be very brief. 0.54. What is the ratio of the Expenses (in $) of Custom duties in 1998 to that in 2001?
Ensure brevity in your answer.  0.44. What is the ratio of the Expenses (in $) of Interest Payments in 1998 to that in 2001?
Ensure brevity in your answer.  0.58. What is the ratio of the Expenses (in $) in Other expenses in 1998 to that in 2001?
Give a very brief answer. 0.59. What is the ratio of the Expenses (in $) in Salary of employees in 1999 to that in 2000?
Offer a very short reply. 0.86. What is the ratio of the Expenses (in $) of Custom duties in 1999 to that in 2000?
Your answer should be very brief. 0.61. What is the ratio of the Expenses (in $) in Interest Payments in 1999 to that in 2000?
Provide a succinct answer. 0.79. What is the ratio of the Expenses (in $) in Other expenses in 1999 to that in 2000?
Ensure brevity in your answer.  0.84. What is the ratio of the Expenses (in $) in Salary of employees in 1999 to that in 2001?
Offer a very short reply. 0.69. What is the ratio of the Expenses (in $) of Custom duties in 1999 to that in 2001?
Give a very brief answer. 0.46. What is the ratio of the Expenses (in $) of Interest Payments in 1999 to that in 2001?
Ensure brevity in your answer.  0.71. What is the ratio of the Expenses (in $) in Other expenses in 1999 to that in 2001?
Keep it short and to the point. 0.74. What is the ratio of the Expenses (in $) in Salary of employees in 2000 to that in 2001?
Make the answer very short. 0.81. What is the ratio of the Expenses (in $) of Custom duties in 2000 to that in 2001?
Provide a succinct answer. 0.76. What is the ratio of the Expenses (in $) in Interest Payments in 2000 to that in 2001?
Provide a short and direct response. 0.9. What is the ratio of the Expenses (in $) in Other expenses in 2000 to that in 2001?
Your answer should be compact. 0.89. What is the difference between the highest and the second highest Expenses (in $) in Salary of employees?
Your response must be concise. 9.04e+08. What is the difference between the highest and the second highest Expenses (in $) in Custom duties?
Make the answer very short. 2.28e+09. What is the difference between the highest and the second highest Expenses (in $) in Interest Payments?
Offer a very short reply. 1.05e+08. What is the difference between the highest and the second highest Expenses (in $) of Other expenses?
Offer a very short reply. 1.32e+09. What is the difference between the highest and the lowest Expenses (in $) in Salary of employees?
Keep it short and to the point. 3.22e+09. What is the difference between the highest and the lowest Expenses (in $) of Custom duties?
Your response must be concise. 6.63e+09. What is the difference between the highest and the lowest Expenses (in $) of Interest Payments?
Your answer should be very brief. 8.97e+08. What is the difference between the highest and the lowest Expenses (in $) of Other expenses?
Your answer should be compact. 7.52e+09. 